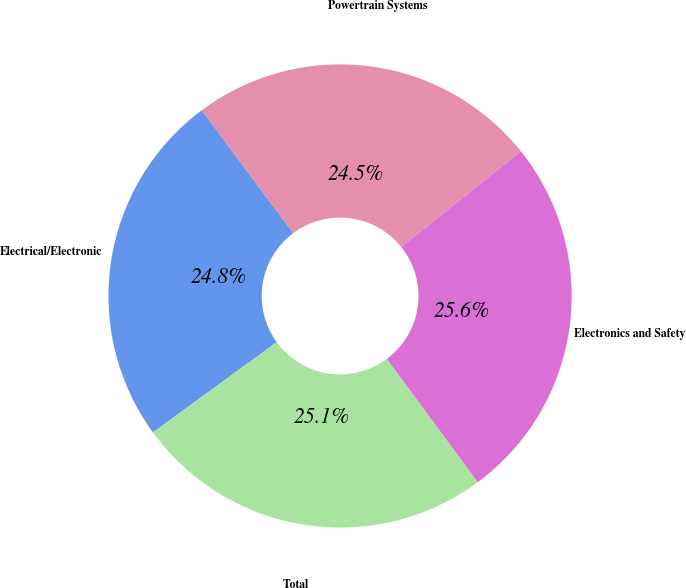Convert chart to OTSL. <chart><loc_0><loc_0><loc_500><loc_500><pie_chart><fcel>Electrical/Electronic<fcel>Powertrain Systems<fcel>Electronics and Safety<fcel>Total<nl><fcel>24.84%<fcel>24.45%<fcel>25.61%<fcel>25.1%<nl></chart> 